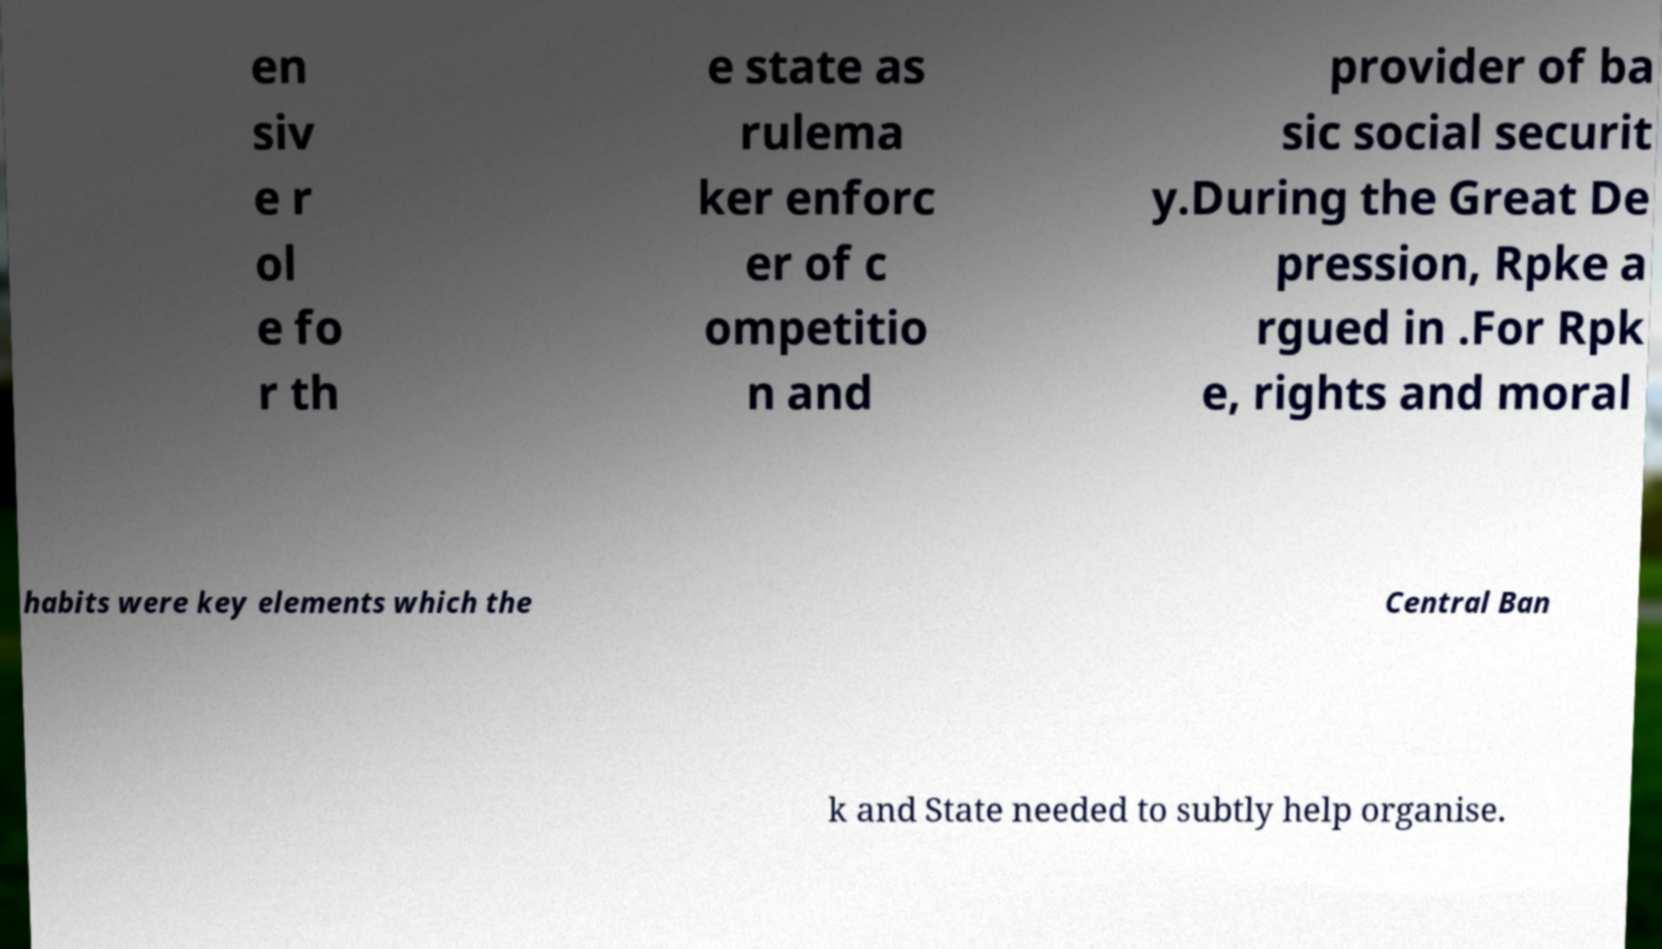What messages or text are displayed in this image? I need them in a readable, typed format. en siv e r ol e fo r th e state as rulema ker enforc er of c ompetitio n and provider of ba sic social securit y.During the Great De pression, Rpke a rgued in .For Rpk e, rights and moral habits were key elements which the Central Ban k and State needed to subtly help organise. 